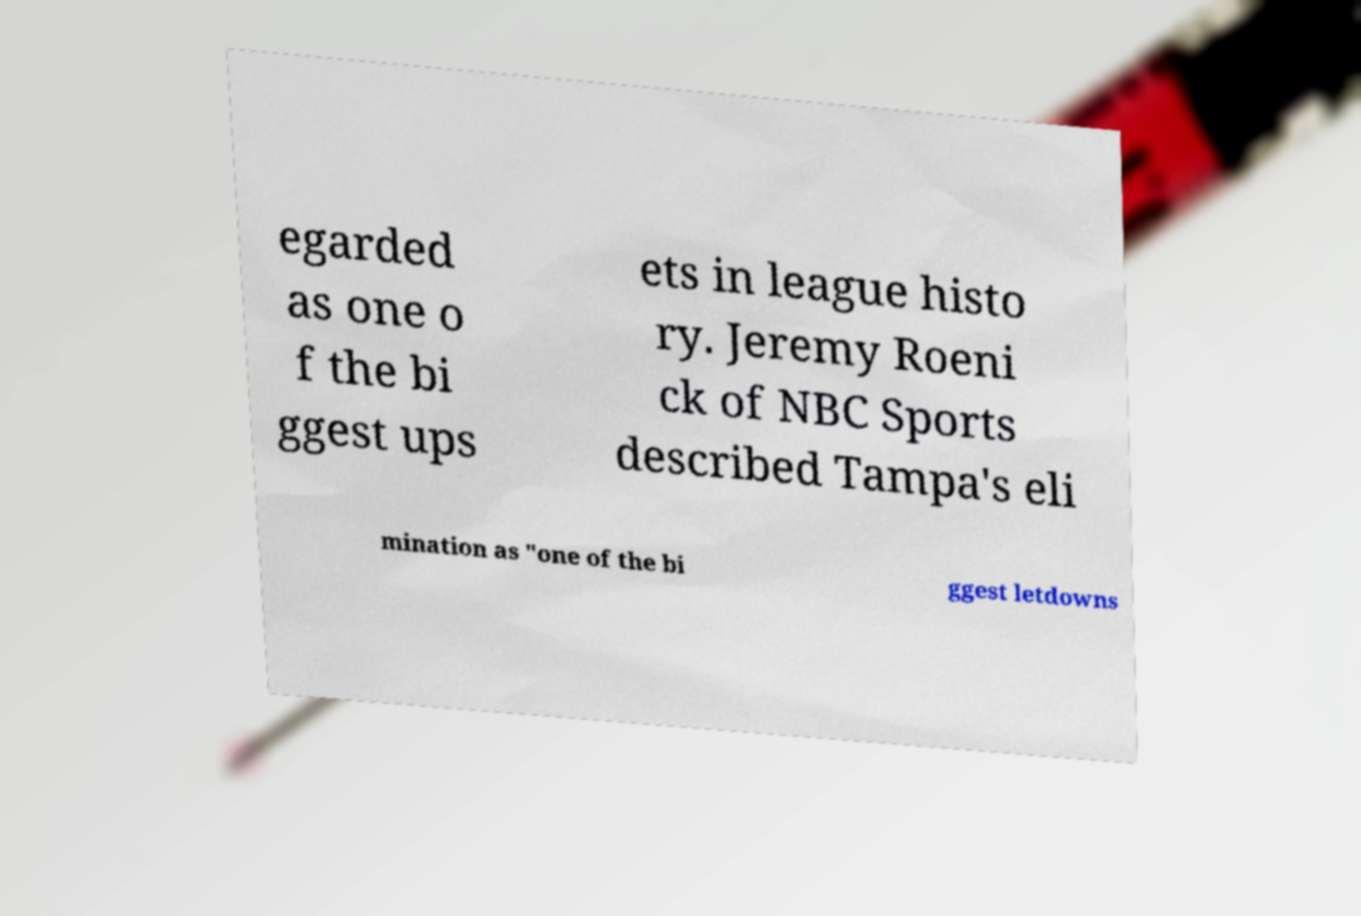Could you assist in decoding the text presented in this image and type it out clearly? egarded as one o f the bi ggest ups ets in league histo ry. Jeremy Roeni ck of NBC Sports described Tampa's eli mination as "one of the bi ggest letdowns 